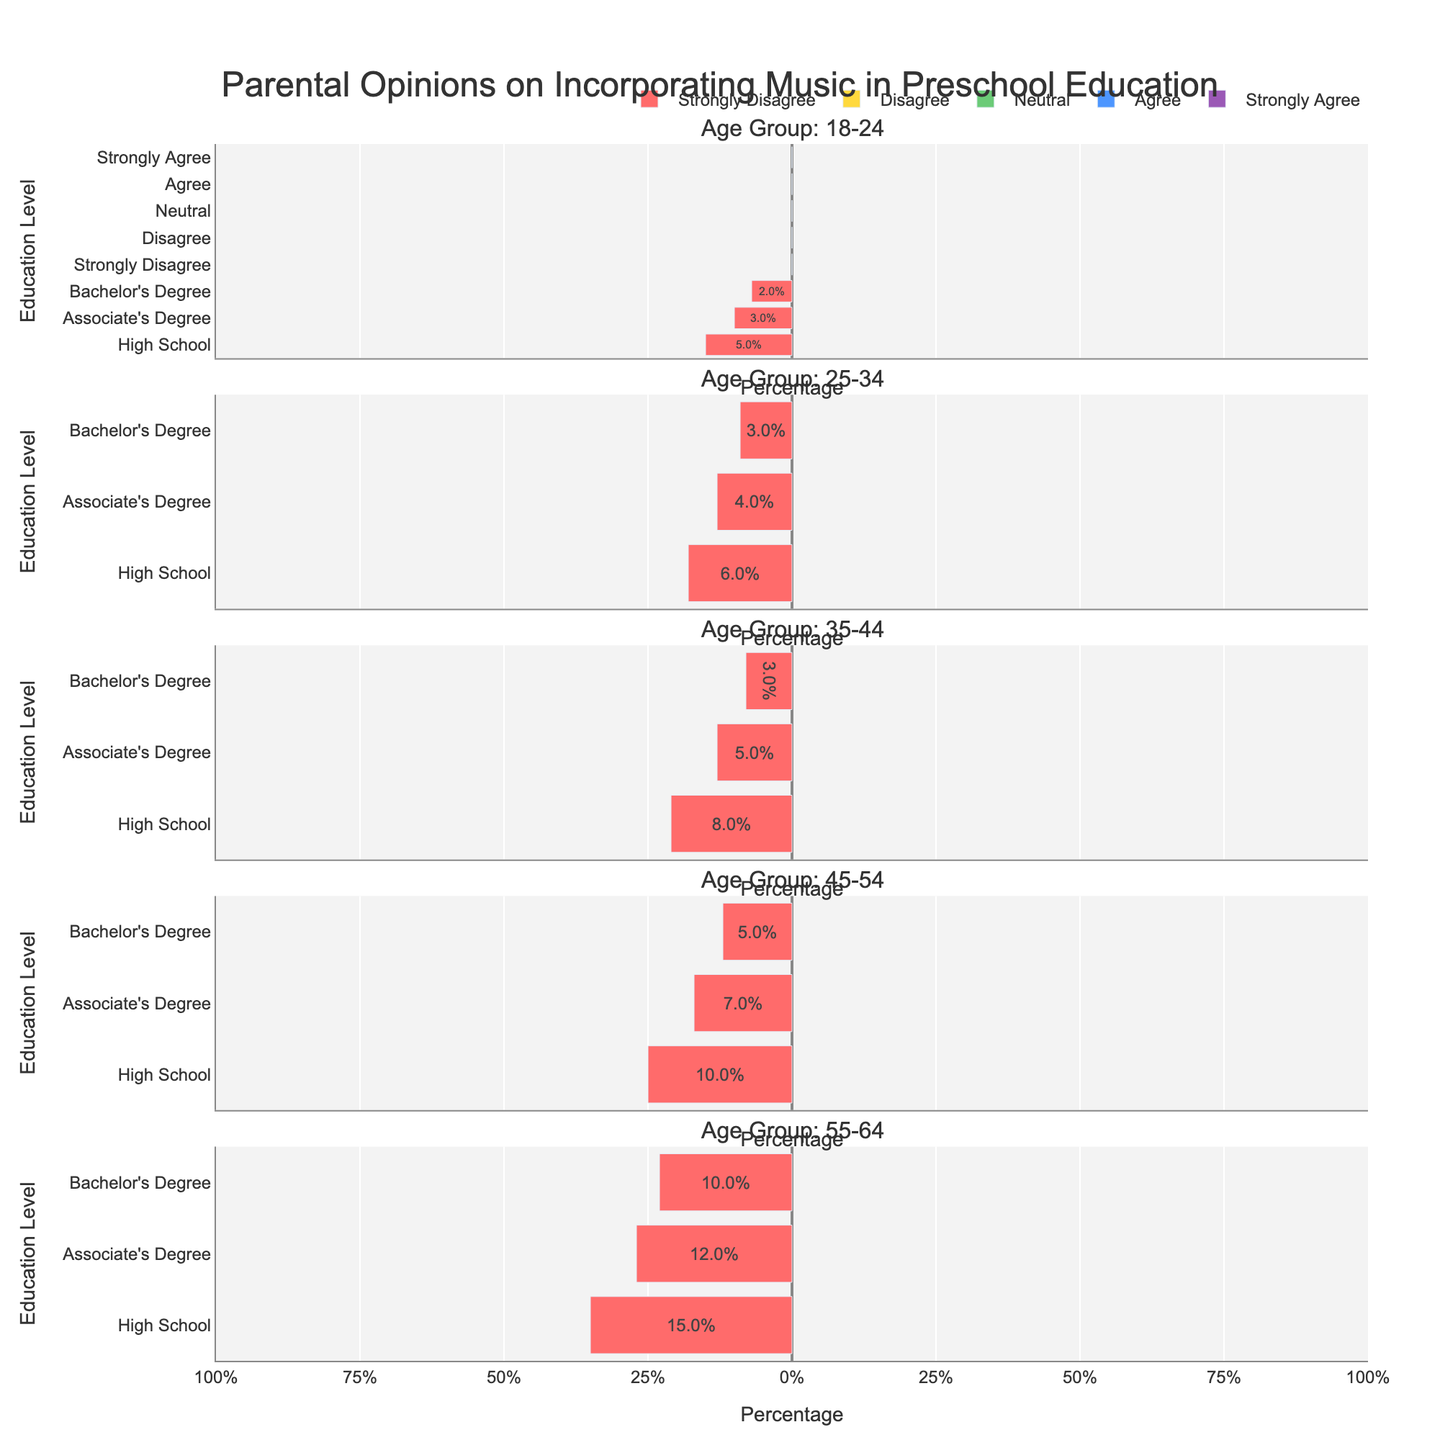What age group and education level have the highest percentage of 'Strongly Agree'? To find this, look for the longest blue bar representing 'Strongly Agree' across all age groups and education levels. For the age group 45-54 with Bachelor’s Degree, the 'Strongly Agree' percentage is the highest at 40%.
Answer: Age group 45-54, Bachelor’s Degree Which age group shows the greatest variation in opinions? To determine this, compare the length of the bars within each age group. The group with the most visually distinct bar lengths across different opinion categories indicates the greatest variation. For age group 55-64 with High School education, the 'Strongly Disagree' and 'Strongly Agree' categories show the most difference in length.
Answer: Age group 55-64 In the age group 18-24, what education level shows the least percentage of 'Neutral'? View the bars across the 18-24 age group for each education level and compare their lengths for 'Neutral' (green bars). The shortest green bar for 'Neutral' in this age group is for Bachelor’s Degree.
Answer: Bachelor’s Degree How does the percentage of 'Agree' compare between age groups 35-44 and 45-54 with Associate's Degree? For both age groups, compare the green bars for 'Agree'. For age group 35-44, the percentage is 38%, and for 45-54, it is 33%.
Answer: 35-44 is higher Which group (age and education level) is the most divided in their opinion? The most divided group will have more evenly distributed lengths across all categories. Age group 55-64 with Associate’s Degree shows an even distribution across categories.
Answer: Age group 55-64, Associate’s Degree 